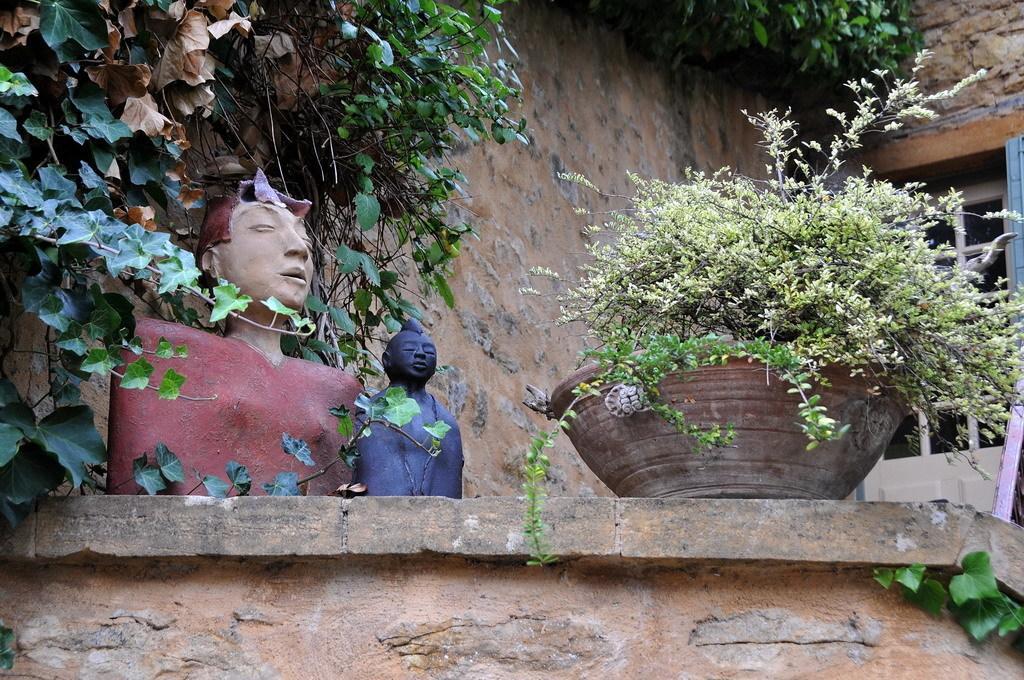Could you give a brief overview of what you see in this image? In the foreground of this image, on the wall, there are plants, two sculptures and in the background, there is a wall, a door and plants on the top. 